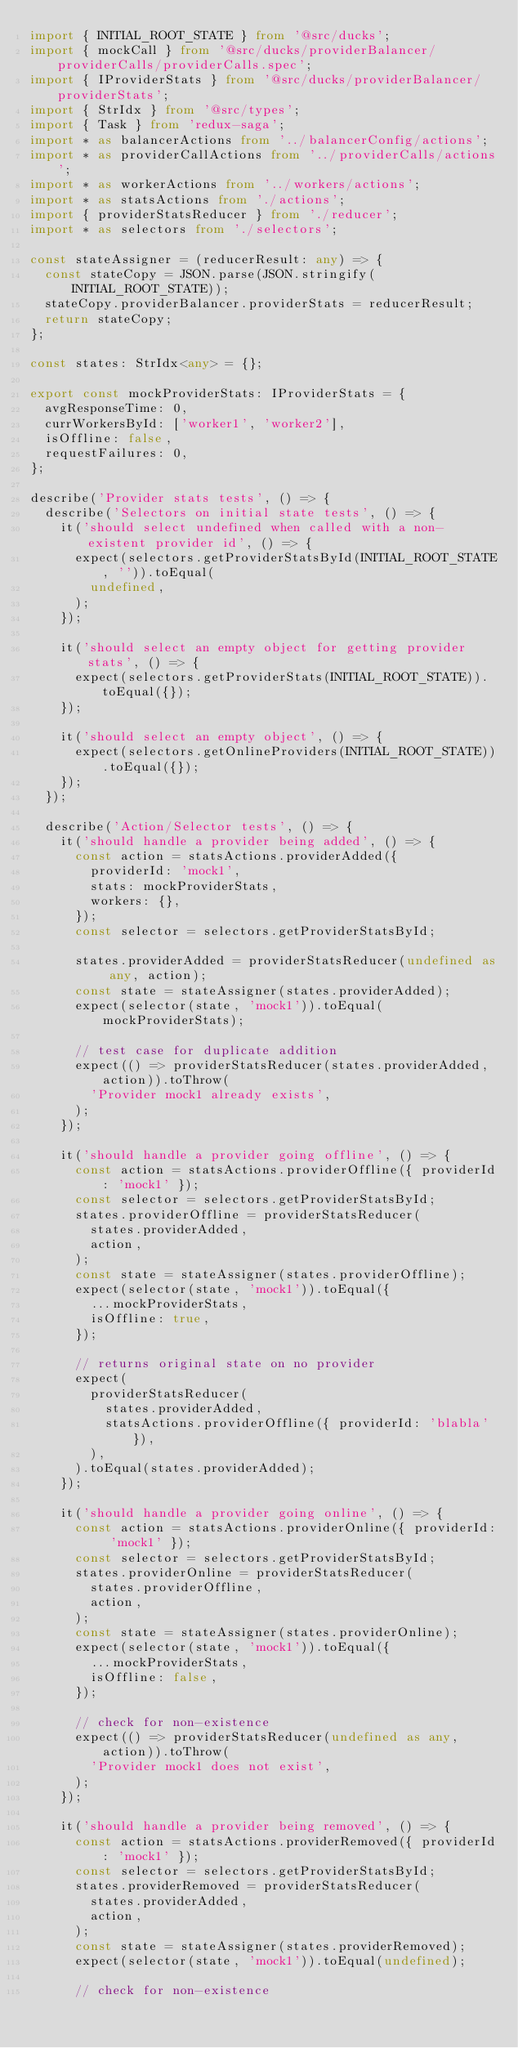<code> <loc_0><loc_0><loc_500><loc_500><_TypeScript_>import { INITIAL_ROOT_STATE } from '@src/ducks';
import { mockCall } from '@src/ducks/providerBalancer/providerCalls/providerCalls.spec';
import { IProviderStats } from '@src/ducks/providerBalancer/providerStats';
import { StrIdx } from '@src/types';
import { Task } from 'redux-saga';
import * as balancerActions from '../balancerConfig/actions';
import * as providerCallActions from '../providerCalls/actions';
import * as workerActions from '../workers/actions';
import * as statsActions from './actions';
import { providerStatsReducer } from './reducer';
import * as selectors from './selectors';

const stateAssigner = (reducerResult: any) => {
  const stateCopy = JSON.parse(JSON.stringify(INITIAL_ROOT_STATE));
  stateCopy.providerBalancer.providerStats = reducerResult;
  return stateCopy;
};

const states: StrIdx<any> = {};

export const mockProviderStats: IProviderStats = {
  avgResponseTime: 0,
  currWorkersById: ['worker1', 'worker2'],
  isOffline: false,
  requestFailures: 0,
};

describe('Provider stats tests', () => {
  describe('Selectors on initial state tests', () => {
    it('should select undefined when called with a non-existent provider id', () => {
      expect(selectors.getProviderStatsById(INITIAL_ROOT_STATE, '')).toEqual(
        undefined,
      );
    });

    it('should select an empty object for getting provider stats', () => {
      expect(selectors.getProviderStats(INITIAL_ROOT_STATE)).toEqual({});
    });

    it('should select an empty object', () => {
      expect(selectors.getOnlineProviders(INITIAL_ROOT_STATE)).toEqual({});
    });
  });

  describe('Action/Selector tests', () => {
    it('should handle a provider being added', () => {
      const action = statsActions.providerAdded({
        providerId: 'mock1',
        stats: mockProviderStats,
        workers: {},
      });
      const selector = selectors.getProviderStatsById;

      states.providerAdded = providerStatsReducer(undefined as any, action);
      const state = stateAssigner(states.providerAdded);
      expect(selector(state, 'mock1')).toEqual(mockProviderStats);

      // test case for duplicate addition
      expect(() => providerStatsReducer(states.providerAdded, action)).toThrow(
        'Provider mock1 already exists',
      );
    });

    it('should handle a provider going offline', () => {
      const action = statsActions.providerOffline({ providerId: 'mock1' });
      const selector = selectors.getProviderStatsById;
      states.providerOffline = providerStatsReducer(
        states.providerAdded,
        action,
      );
      const state = stateAssigner(states.providerOffline);
      expect(selector(state, 'mock1')).toEqual({
        ...mockProviderStats,
        isOffline: true,
      });

      // returns original state on no provider
      expect(
        providerStatsReducer(
          states.providerAdded,
          statsActions.providerOffline({ providerId: 'blabla' }),
        ),
      ).toEqual(states.providerAdded);
    });

    it('should handle a provider going online', () => {
      const action = statsActions.providerOnline({ providerId: 'mock1' });
      const selector = selectors.getProviderStatsById;
      states.providerOnline = providerStatsReducer(
        states.providerOffline,
        action,
      );
      const state = stateAssigner(states.providerOnline);
      expect(selector(state, 'mock1')).toEqual({
        ...mockProviderStats,
        isOffline: false,
      });

      // check for non-existence
      expect(() => providerStatsReducer(undefined as any, action)).toThrow(
        'Provider mock1 does not exist',
      );
    });

    it('should handle a provider being removed', () => {
      const action = statsActions.providerRemoved({ providerId: 'mock1' });
      const selector = selectors.getProviderStatsById;
      states.providerRemoved = providerStatsReducer(
        states.providerAdded,
        action,
      );
      const state = stateAssigner(states.providerRemoved);
      expect(selector(state, 'mock1')).toEqual(undefined);

      // check for non-existence</code> 